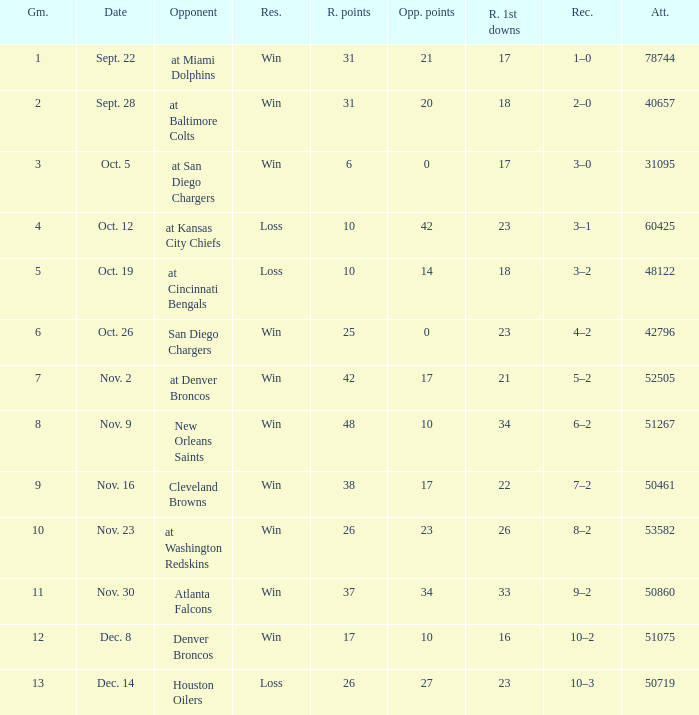What's the record in the game played against 42? 3–1. 